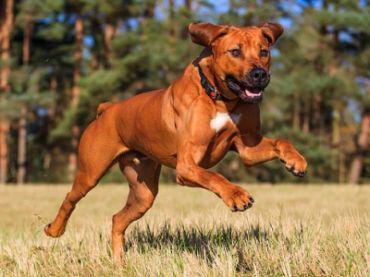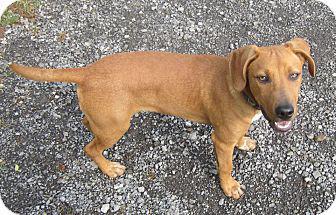The first image is the image on the left, the second image is the image on the right. For the images shown, is this caption "One image includes a sitting dog wearing a collar, and the other image features a dog with one raised front paw." true? Answer yes or no. No. The first image is the image on the left, the second image is the image on the right. Assess this claim about the two images: "The right image contains exactly two dogs.". Correct or not? Answer yes or no. No. 